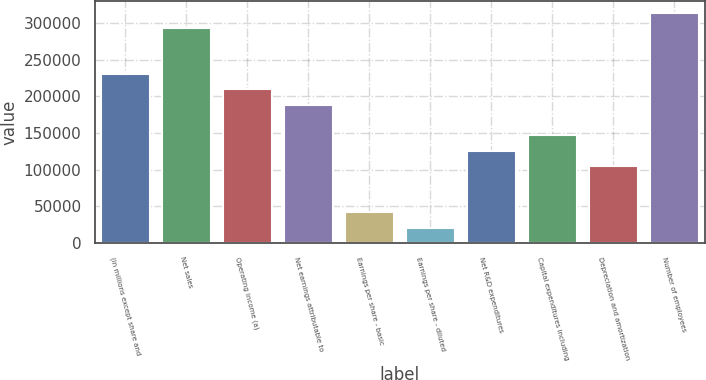<chart> <loc_0><loc_0><loc_500><loc_500><bar_chart><fcel>(in millions except share and<fcel>Net sales<fcel>Operating income (a)<fcel>Net earnings attributable to<fcel>Earnings per share - basic<fcel>Earnings per share - diluted<fcel>Net R&D expenditures<fcel>Capital expenditures including<fcel>Depreciation and amortization<fcel>Number of employees<nl><fcel>230446<fcel>293294<fcel>209496<fcel>188546<fcel>41899.7<fcel>20950.2<fcel>125698<fcel>146647<fcel>104748<fcel>314244<nl></chart> 